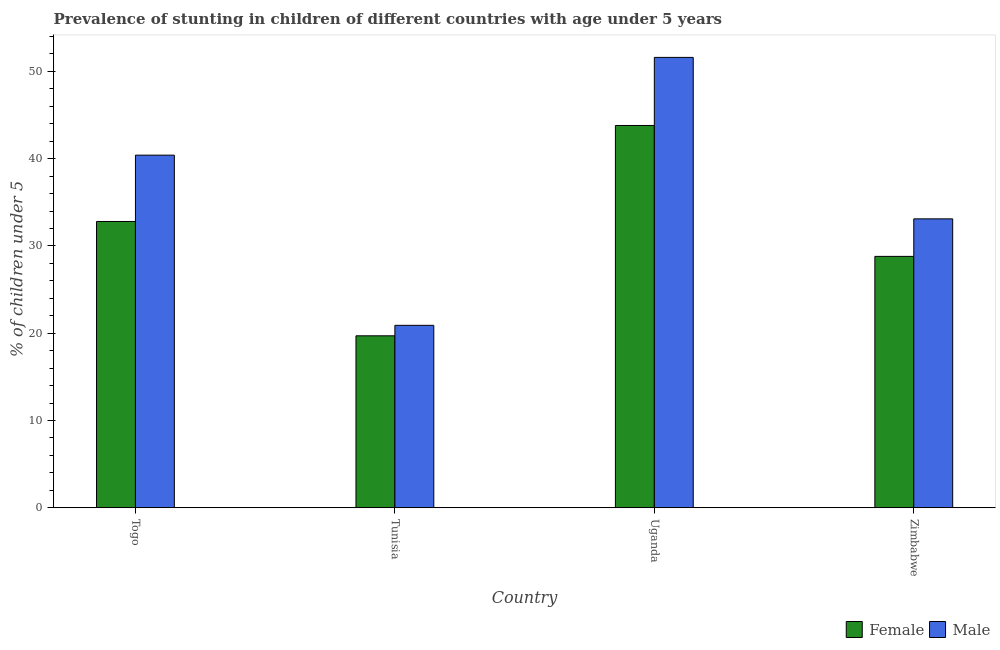How many different coloured bars are there?
Give a very brief answer. 2. Are the number of bars per tick equal to the number of legend labels?
Your response must be concise. Yes. What is the label of the 2nd group of bars from the left?
Provide a succinct answer. Tunisia. What is the percentage of stunted male children in Tunisia?
Offer a very short reply. 20.9. Across all countries, what is the maximum percentage of stunted male children?
Make the answer very short. 51.6. Across all countries, what is the minimum percentage of stunted male children?
Offer a terse response. 20.9. In which country was the percentage of stunted male children maximum?
Offer a very short reply. Uganda. In which country was the percentage of stunted female children minimum?
Your answer should be compact. Tunisia. What is the total percentage of stunted female children in the graph?
Offer a terse response. 125.1. What is the difference between the percentage of stunted female children in Tunisia and that in Zimbabwe?
Your answer should be compact. -9.1. What is the difference between the percentage of stunted female children in Tunisia and the percentage of stunted male children in Togo?
Ensure brevity in your answer.  -20.7. What is the average percentage of stunted female children per country?
Give a very brief answer. 31.27. What is the difference between the percentage of stunted male children and percentage of stunted female children in Zimbabwe?
Keep it short and to the point. 4.3. What is the ratio of the percentage of stunted male children in Tunisia to that in Zimbabwe?
Offer a terse response. 0.63. Is the difference between the percentage of stunted female children in Tunisia and Zimbabwe greater than the difference between the percentage of stunted male children in Tunisia and Zimbabwe?
Provide a short and direct response. Yes. What is the difference between the highest and the second highest percentage of stunted male children?
Your response must be concise. 11.2. What is the difference between the highest and the lowest percentage of stunted female children?
Make the answer very short. 24.1. What does the 1st bar from the left in Zimbabwe represents?
Your response must be concise. Female. What is the difference between two consecutive major ticks on the Y-axis?
Your response must be concise. 10. Are the values on the major ticks of Y-axis written in scientific E-notation?
Offer a terse response. No. How many legend labels are there?
Make the answer very short. 2. What is the title of the graph?
Provide a succinct answer. Prevalence of stunting in children of different countries with age under 5 years. What is the label or title of the X-axis?
Your answer should be compact. Country. What is the label or title of the Y-axis?
Your answer should be compact.  % of children under 5. What is the  % of children under 5 of Female in Togo?
Your answer should be compact. 32.8. What is the  % of children under 5 in Male in Togo?
Ensure brevity in your answer.  40.4. What is the  % of children under 5 of Female in Tunisia?
Keep it short and to the point. 19.7. What is the  % of children under 5 of Male in Tunisia?
Make the answer very short. 20.9. What is the  % of children under 5 of Female in Uganda?
Give a very brief answer. 43.8. What is the  % of children under 5 in Male in Uganda?
Your response must be concise. 51.6. What is the  % of children under 5 in Female in Zimbabwe?
Make the answer very short. 28.8. What is the  % of children under 5 in Male in Zimbabwe?
Your answer should be very brief. 33.1. Across all countries, what is the maximum  % of children under 5 of Female?
Your response must be concise. 43.8. Across all countries, what is the maximum  % of children under 5 in Male?
Give a very brief answer. 51.6. Across all countries, what is the minimum  % of children under 5 of Female?
Ensure brevity in your answer.  19.7. Across all countries, what is the minimum  % of children under 5 of Male?
Keep it short and to the point. 20.9. What is the total  % of children under 5 in Female in the graph?
Provide a succinct answer. 125.1. What is the total  % of children under 5 in Male in the graph?
Keep it short and to the point. 146. What is the difference between the  % of children under 5 of Female in Togo and that in Zimbabwe?
Provide a short and direct response. 4. What is the difference between the  % of children under 5 of Male in Togo and that in Zimbabwe?
Give a very brief answer. 7.3. What is the difference between the  % of children under 5 in Female in Tunisia and that in Uganda?
Offer a terse response. -24.1. What is the difference between the  % of children under 5 of Male in Tunisia and that in Uganda?
Provide a succinct answer. -30.7. What is the difference between the  % of children under 5 in Female in Tunisia and that in Zimbabwe?
Your response must be concise. -9.1. What is the difference between the  % of children under 5 in Male in Tunisia and that in Zimbabwe?
Make the answer very short. -12.2. What is the difference between the  % of children under 5 in Male in Uganda and that in Zimbabwe?
Provide a short and direct response. 18.5. What is the difference between the  % of children under 5 in Female in Togo and the  % of children under 5 in Male in Tunisia?
Your response must be concise. 11.9. What is the difference between the  % of children under 5 in Female in Togo and the  % of children under 5 in Male in Uganda?
Offer a terse response. -18.8. What is the difference between the  % of children under 5 in Female in Togo and the  % of children under 5 in Male in Zimbabwe?
Make the answer very short. -0.3. What is the difference between the  % of children under 5 in Female in Tunisia and the  % of children under 5 in Male in Uganda?
Provide a short and direct response. -31.9. What is the difference between the  % of children under 5 of Female in Tunisia and the  % of children under 5 of Male in Zimbabwe?
Offer a very short reply. -13.4. What is the difference between the  % of children under 5 of Female in Uganda and the  % of children under 5 of Male in Zimbabwe?
Ensure brevity in your answer.  10.7. What is the average  % of children under 5 of Female per country?
Give a very brief answer. 31.27. What is the average  % of children under 5 of Male per country?
Give a very brief answer. 36.5. What is the difference between the  % of children under 5 in Female and  % of children under 5 in Male in Togo?
Give a very brief answer. -7.6. What is the difference between the  % of children under 5 of Female and  % of children under 5 of Male in Tunisia?
Your answer should be compact. -1.2. What is the difference between the  % of children under 5 of Female and  % of children under 5 of Male in Uganda?
Provide a succinct answer. -7.8. What is the difference between the  % of children under 5 of Female and  % of children under 5 of Male in Zimbabwe?
Provide a short and direct response. -4.3. What is the ratio of the  % of children under 5 in Female in Togo to that in Tunisia?
Make the answer very short. 1.67. What is the ratio of the  % of children under 5 of Male in Togo to that in Tunisia?
Give a very brief answer. 1.93. What is the ratio of the  % of children under 5 in Female in Togo to that in Uganda?
Your answer should be compact. 0.75. What is the ratio of the  % of children under 5 of Male in Togo to that in Uganda?
Provide a succinct answer. 0.78. What is the ratio of the  % of children under 5 of Female in Togo to that in Zimbabwe?
Your answer should be compact. 1.14. What is the ratio of the  % of children under 5 in Male in Togo to that in Zimbabwe?
Keep it short and to the point. 1.22. What is the ratio of the  % of children under 5 in Female in Tunisia to that in Uganda?
Ensure brevity in your answer.  0.45. What is the ratio of the  % of children under 5 of Male in Tunisia to that in Uganda?
Offer a terse response. 0.41. What is the ratio of the  % of children under 5 of Female in Tunisia to that in Zimbabwe?
Provide a succinct answer. 0.68. What is the ratio of the  % of children under 5 of Male in Tunisia to that in Zimbabwe?
Ensure brevity in your answer.  0.63. What is the ratio of the  % of children under 5 of Female in Uganda to that in Zimbabwe?
Your answer should be very brief. 1.52. What is the ratio of the  % of children under 5 in Male in Uganda to that in Zimbabwe?
Your response must be concise. 1.56. What is the difference between the highest and the second highest  % of children under 5 in Male?
Make the answer very short. 11.2. What is the difference between the highest and the lowest  % of children under 5 in Female?
Provide a short and direct response. 24.1. What is the difference between the highest and the lowest  % of children under 5 of Male?
Offer a terse response. 30.7. 